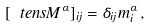Convert formula to latex. <formula><loc_0><loc_0><loc_500><loc_500>[ { \ t e n s { M } } ^ { \alpha } ] _ { i j } = \delta _ { i j } m ^ { \alpha } _ { i } \, ,</formula> 